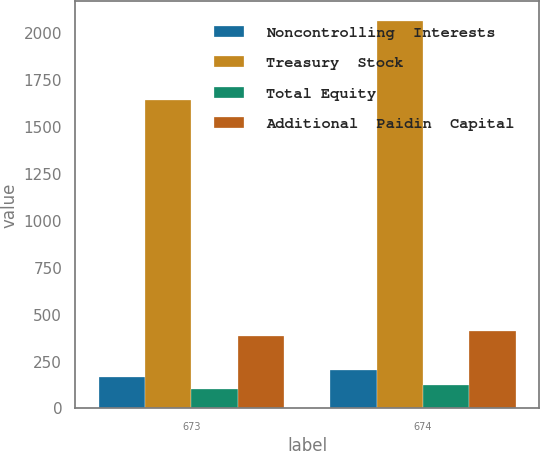<chart> <loc_0><loc_0><loc_500><loc_500><stacked_bar_chart><ecel><fcel>673<fcel>674<nl><fcel>Noncontrolling  Interests<fcel>169.2<fcel>204.6<nl><fcel>Treasury  Stock<fcel>1644.1<fcel>2067<nl><fcel>Total Equity<fcel>104.8<fcel>124.2<nl><fcel>Additional  Paidin  Capital<fcel>387.3<fcel>412.7<nl></chart> 